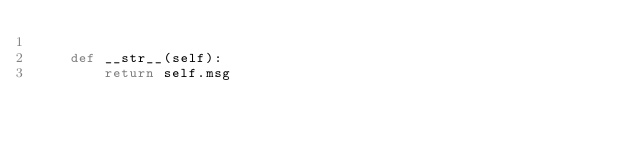Convert code to text. <code><loc_0><loc_0><loc_500><loc_500><_Python_>
    def __str__(self):
        return self.msg
</code> 